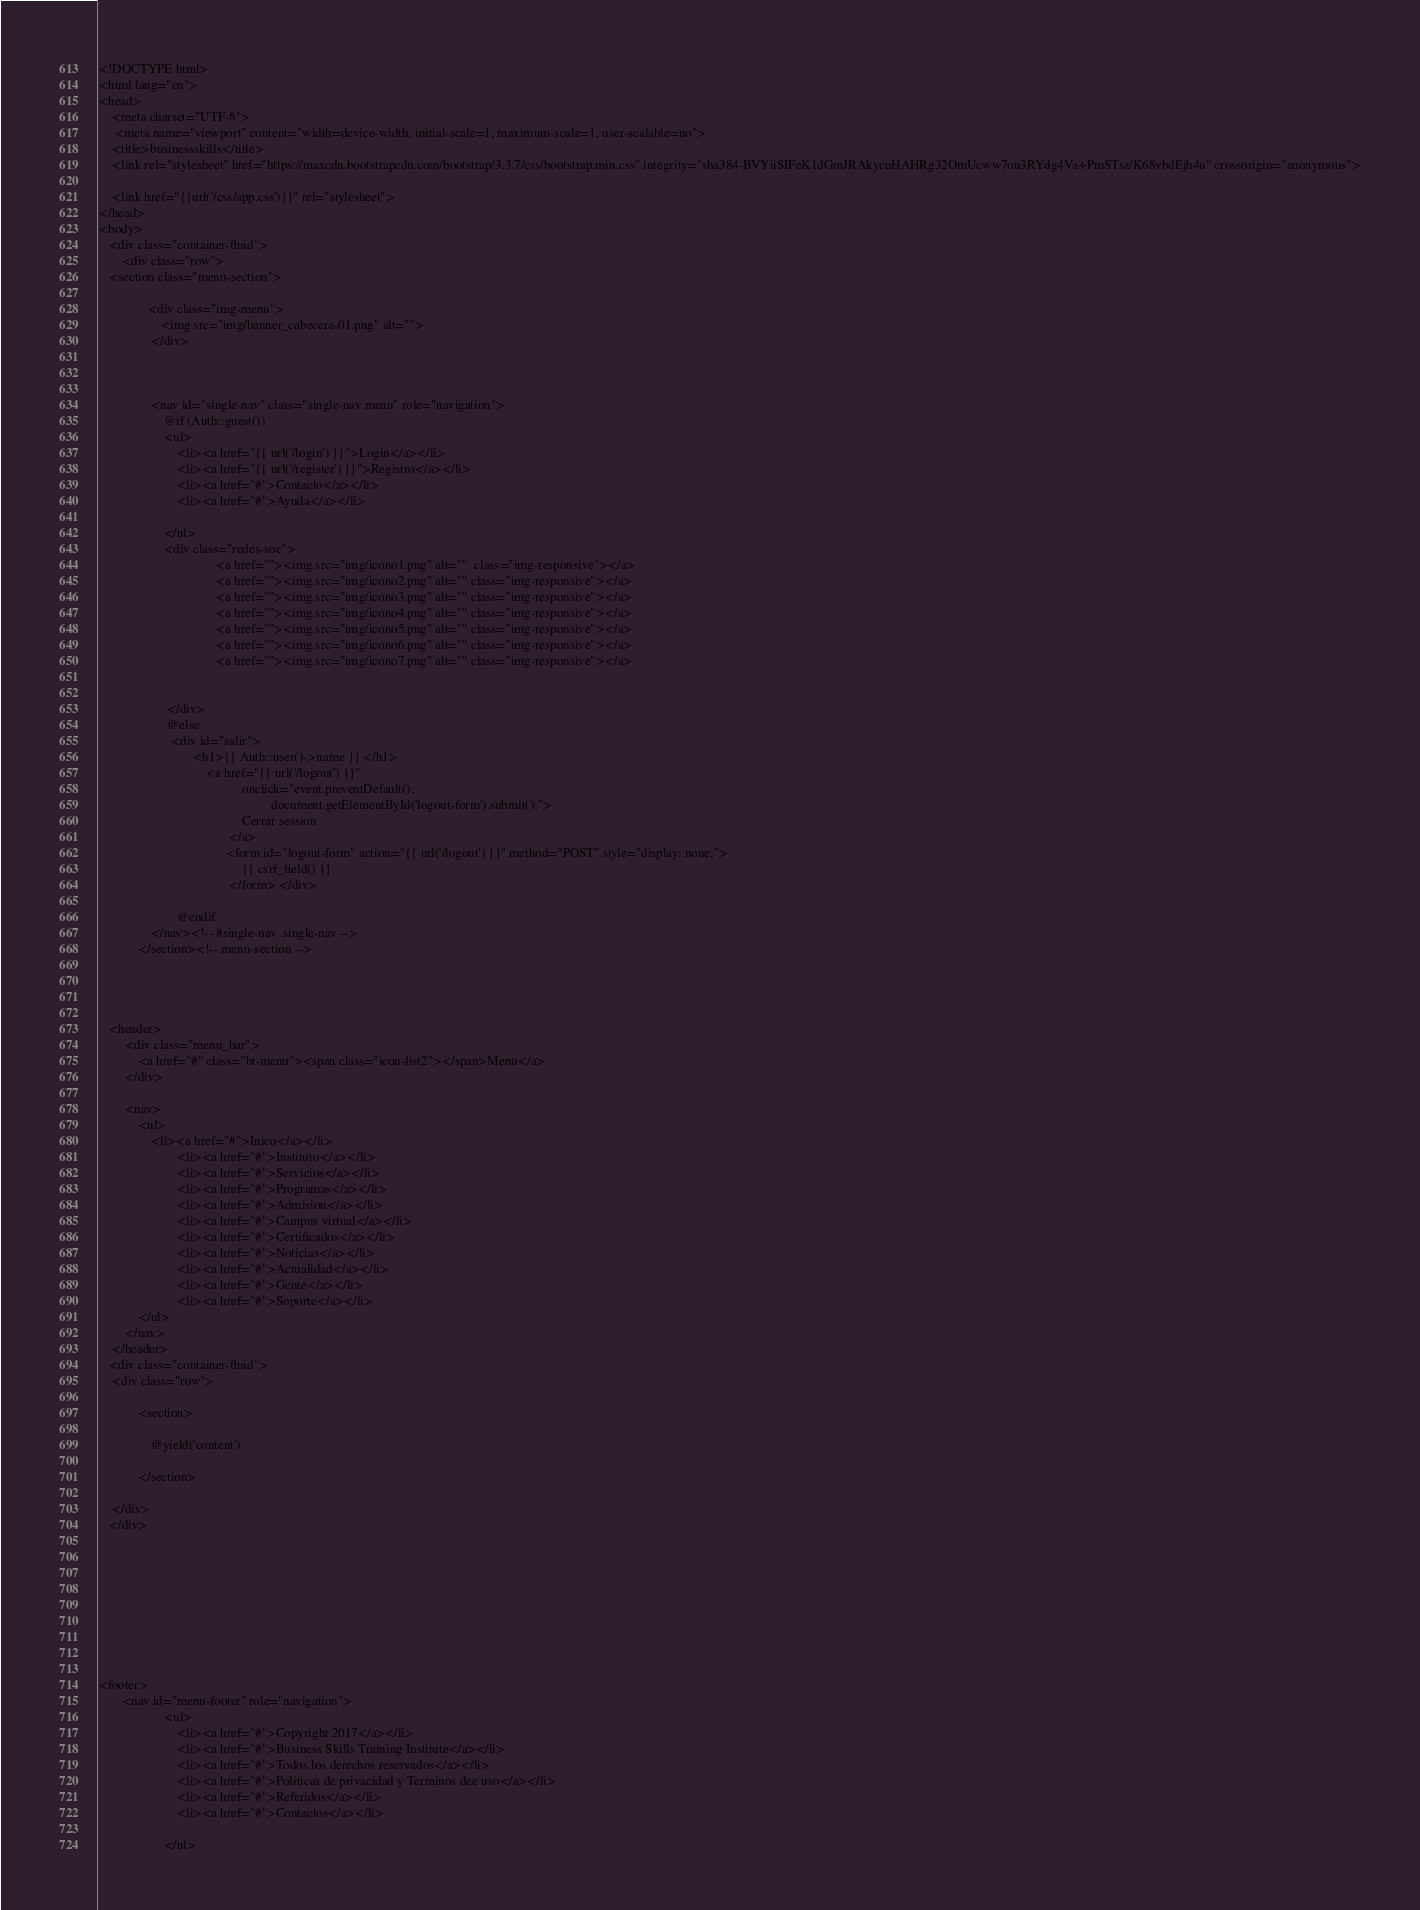<code> <loc_0><loc_0><loc_500><loc_500><_PHP_><!DOCTYPE html>
<html lang="en">
<head>
    <meta charset="UTF-8">
     <meta name="viewport" content="width=device-width, initial-scale=1, maximum-scale=1, user-scalable=no">
    <title>businessskills</title>
    <link rel="stylesheet" href="https://maxcdn.bootstrapcdn.com/bootstrap/3.3.7/css/bootstrap.min.css" integrity="sha384-BVYiiSIFeK1dGmJRAkycuHAHRg32OmUcww7on3RYdg4Va+PmSTsz/K68vbdEjh4u" crossorigin="anonymous">

    <link href="{{url('/css/app.css')}}" rel="stylesheet">
</head>
<body>
   <div class="container-fluid">
       <div class="row">
   <section class="menu-section"> 
              
               <div class="img-menu">
                   <img src="img/banner_cabecera-01.png" alt="">
                </div>
                
                
                
                <nav id="single-nav" class="single-nav menu" role="navigation">
                    @if (Auth::guest())
                    <ul>
                        <li><a href="{{ url('/login') }}">Login</a></li>
                        <li><a href="{{ url('/register') }}">Registro</a></li>
                        <li><a href="#">Contacto</a></li>
                        <li><a href="#">Ayuda</a></li>
                         
                    </ul>
                    <div class="redes-soc">
                                    <a href=""><img src="img/icono1.png" alt=""  class="img-responsive"></a>
                                    <a href=""><img src="img/icono2.png" alt="" class="img-responsive"></a>
                                    <a href=""><img src="img/icono3.png" alt="" class="img-responsive"></a>
                                    <a href=""><img src="img/icono4.png" alt="" class="img-responsive"></a>
                                    <a href=""><img src="img/icono5.png" alt="" class="img-responsive"></a>
                                    <a href=""><img src="img/icono6.png" alt="" class="img-responsive"></a>
                                    <a href=""><img src="img/icono7.png" alt="" class="img-responsive"></a>
                                     
                                
                     </div>
                     @else
                      <div id="salir">
                             <h1>{{ Auth::user()->name }} </h1>
                                 <a href="{{ url('/logout') }}"
                                            onclick="event.preventDefault();
                                                     document.getElementById('logout-form').submit();">
                                            Cerrar session
                                        </a>
                                       <form id="logout-form" action="{{ url('/logout') }}" method="POST" style="display: none;">
                                            {{ csrf_field() }}
                                        </form> </div>
                            
                        @endif       
                </nav><!-- #single-nav .single-nav -->
            </section><!-- menu-section -->

   
   
   
   <header>
		<div class="menu_bar">
			<a href="#" class="bt-menu"><span class="icon-list2"></span>Menu</a>
		</div>
 
		<nav>
			<ul>
				<li><a href="#">Inico</a></li>
                        <li><a href="#">Instituto</a></li>
                        <li><a href="#">Servicios</a></li>
                        <li><a href="#">Programas</a></li>
                        <li><a href="#">Admision</a></li>
                        <li><a href="#">Campus virtual</a></li>
                        <li><a href="#">Certificados</a></li>
                        <li><a href="#">Noticias</a></li>
                        <li><a href="#">Actualidad</a></li>
                        <li><a href="#">Gente</a></li>
                        <li><a href="#">Soporte</a></li>
			</ul>
		</nav>
	</header>
   <div class="container-fluid">
    <div class="row">
    
            <section>
              
                @yield('content')

            </section>

    </div>
   </div> 
   
   
   
   
   
   
   


<footer>
       <nav id="menu-footer" role="navigation">
                    <ul>
                        <li><a href="#">Copyright 2017</a></li>
                        <li><a href="#">Business Skills Training Institute</a></li>
                        <li><a href="#">Todos los derechos reservados</a></li>
                        <li><a href="#">Politicas de privacidad y Terminos dee uso</a></li>
                        <li><a href="#">Referidos</a></li>
                        <li><a href="#">Contactos</a></li>
                        
                    </ul></code> 